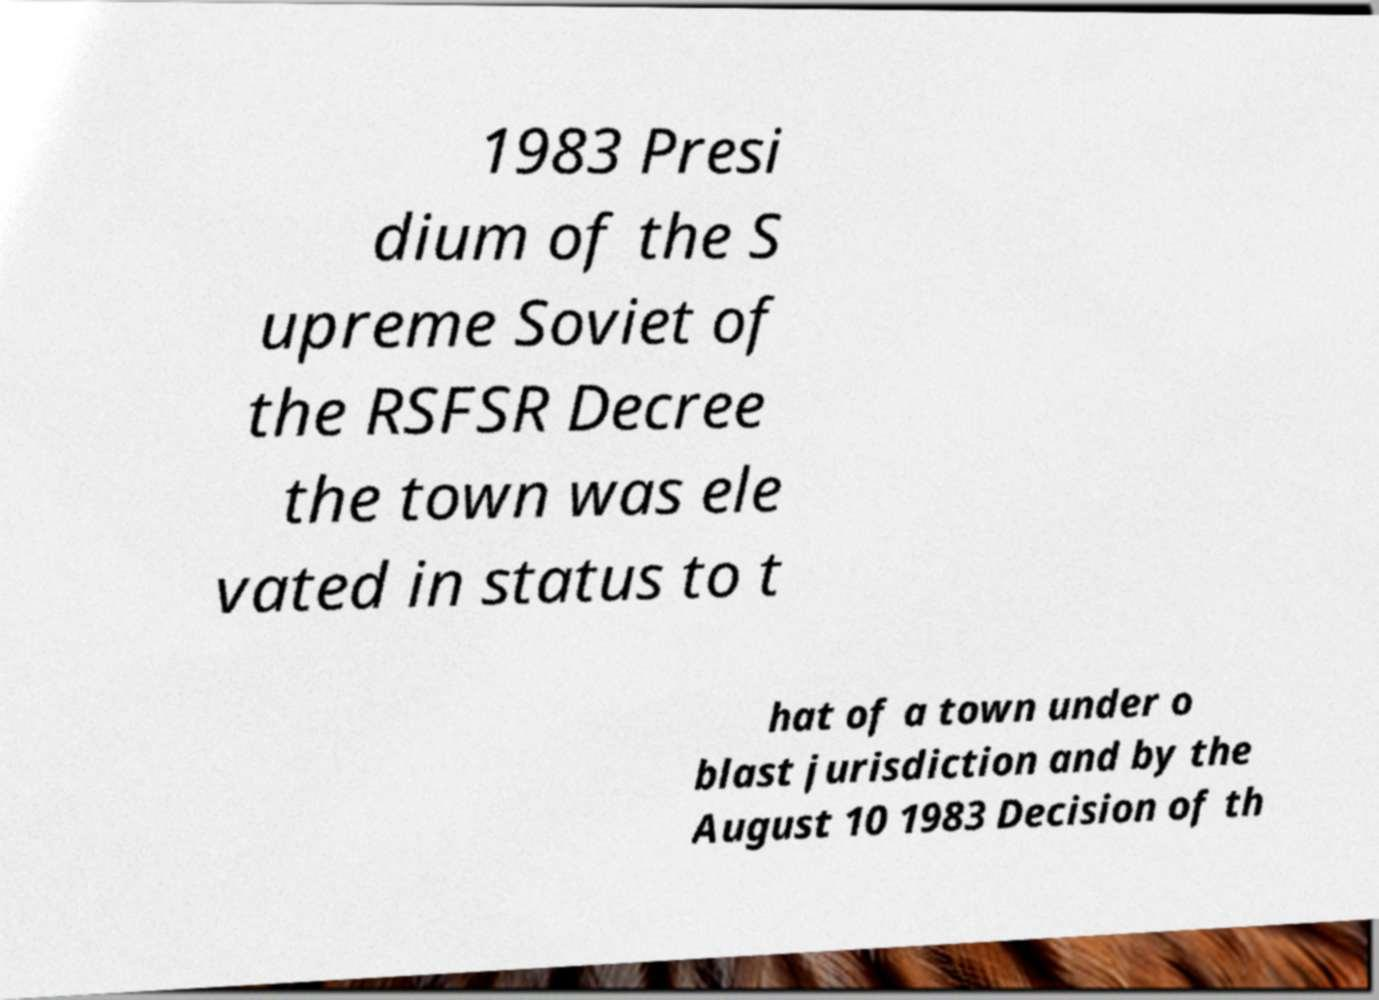I need the written content from this picture converted into text. Can you do that? 1983 Presi dium of the S upreme Soviet of the RSFSR Decree the town was ele vated in status to t hat of a town under o blast jurisdiction and by the August 10 1983 Decision of th 